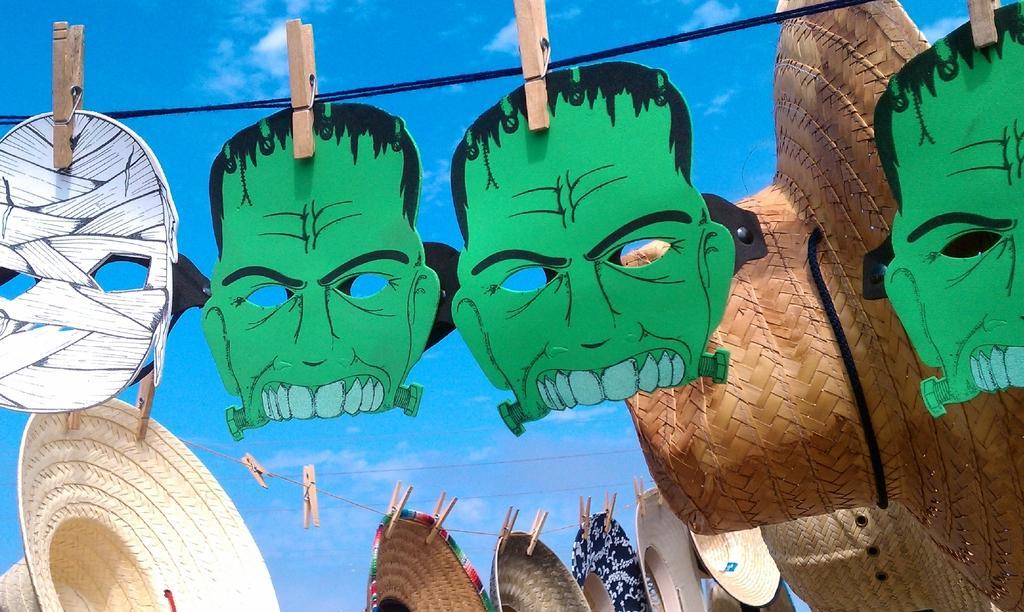Could you give a brief overview of what you see in this image? In this image I see 4 masks over here in which these 3 are of green and black in color and this mask is of white and black in color and I see many hats and these all are on the wires and I see clips on it and in the background I see the sky. 